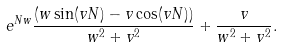Convert formula to latex. <formula><loc_0><loc_0><loc_500><loc_500>e ^ { N w } \frac { ( w \sin ( v N ) - v \cos ( v N ) ) } { w ^ { 2 } + v ^ { 2 } } + \frac { v } { w ^ { 2 } + v ^ { 2 } } .</formula> 